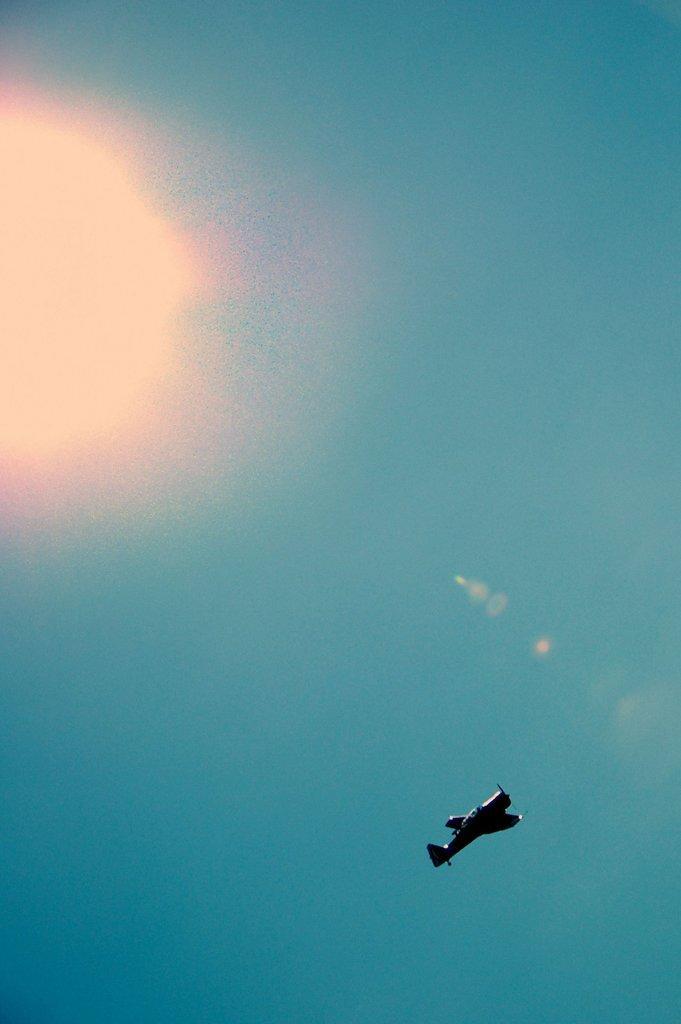How would you summarize this image in a sentence or two? In this picture we can see an airplane flying and we can see sky in the background. 